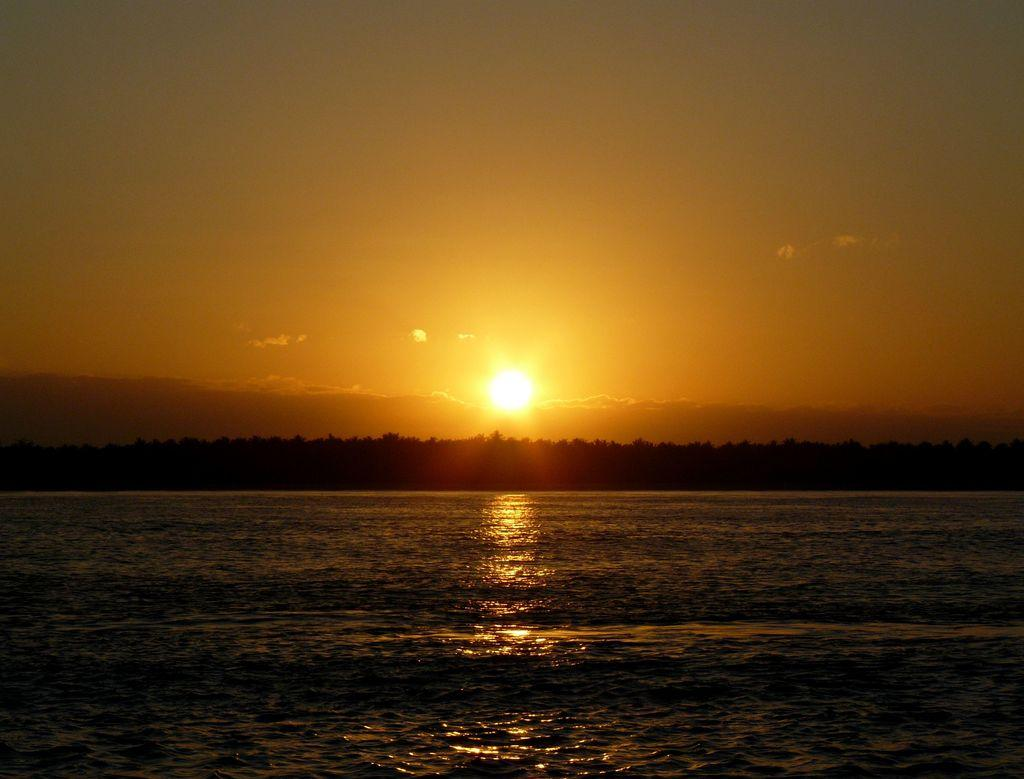What can be seen in the image? There is water visible in the image. What is located behind the water? There is a group of trees behind the water. What is visible in the sky in the background of the image? The sun is visible in the sky in the background of the image. Reasoning: Let's think step by step by step in order to produce the conversation. We start by identifying the main subject in the image, which is the water. Then, we expand the conversation to include other elements that are also visible, such as the group of trees and the sun in the sky. Each question is designed to elicit a specific detail about the image that is known from the provided facts. Absurd Question/Answer: Can you tell me how many friends are combing the cattle in the image? There are no friends or cattle present in the image; it features water and a group of trees. 